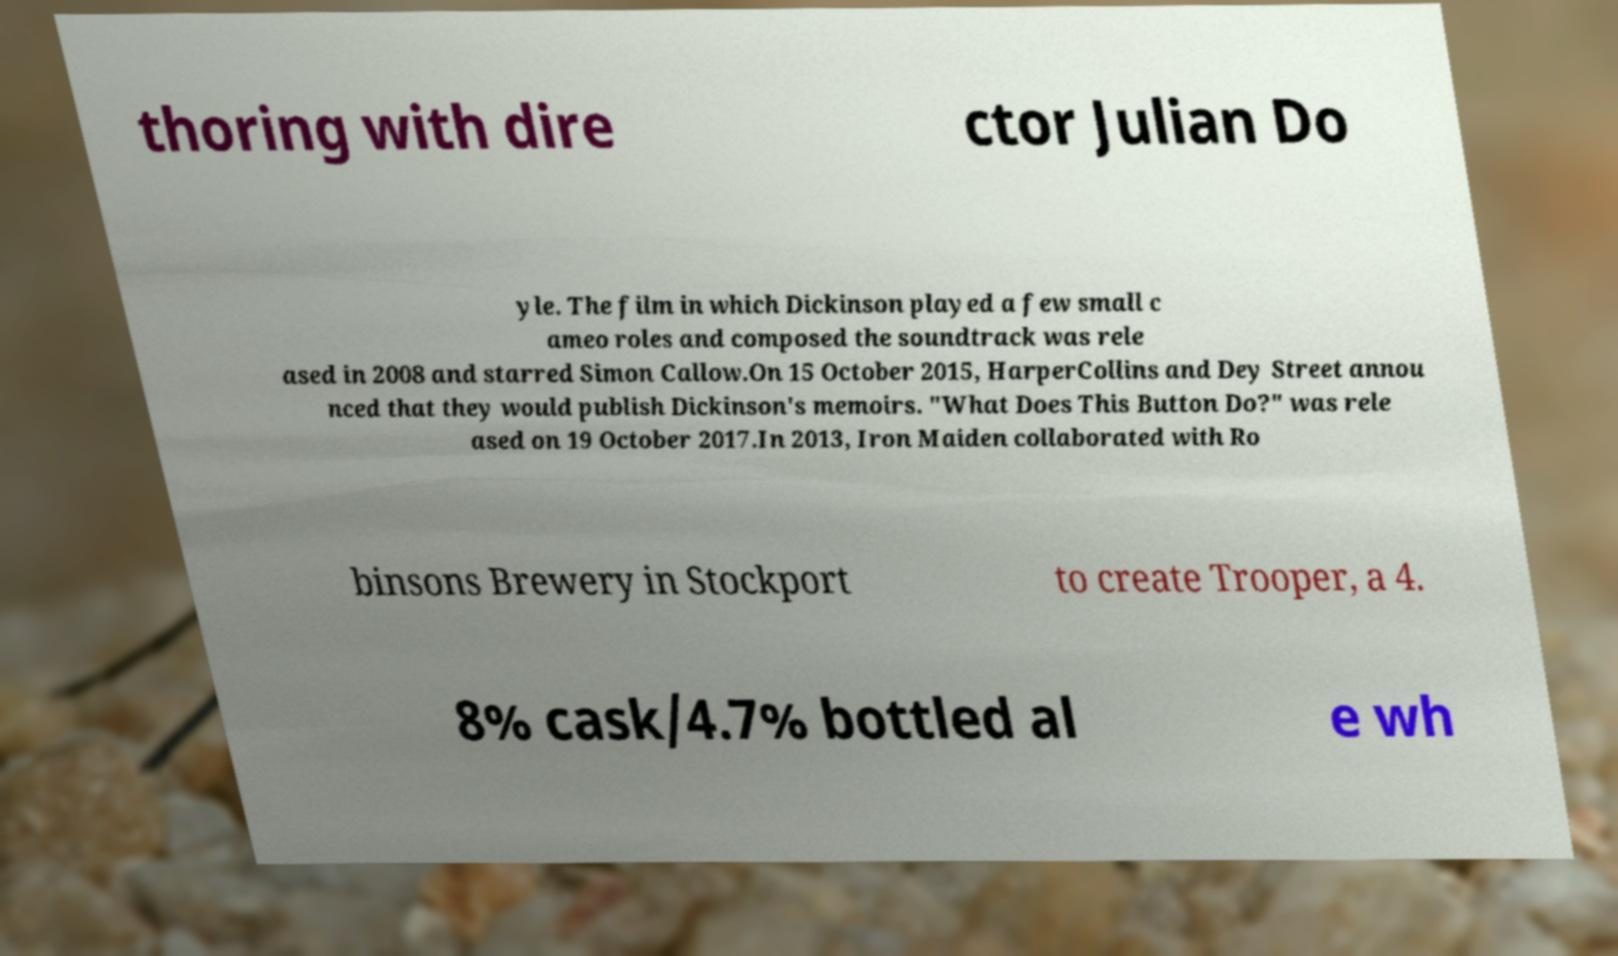I need the written content from this picture converted into text. Can you do that? thoring with dire ctor Julian Do yle. The film in which Dickinson played a few small c ameo roles and composed the soundtrack was rele ased in 2008 and starred Simon Callow.On 15 October 2015, HarperCollins and Dey Street annou nced that they would publish Dickinson's memoirs. "What Does This Button Do?" was rele ased on 19 October 2017.In 2013, Iron Maiden collaborated with Ro binsons Brewery in Stockport to create Trooper, a 4. 8% cask/4.7% bottled al e wh 